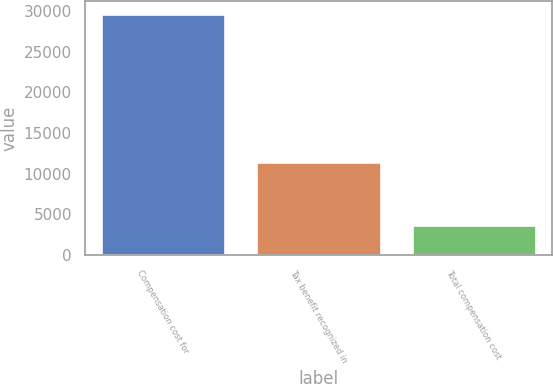Convert chart. <chart><loc_0><loc_0><loc_500><loc_500><bar_chart><fcel>Compensation cost for<fcel>Tax benefit recognized in<fcel>Total compensation cost<nl><fcel>29672<fcel>11471<fcel>3636<nl></chart> 